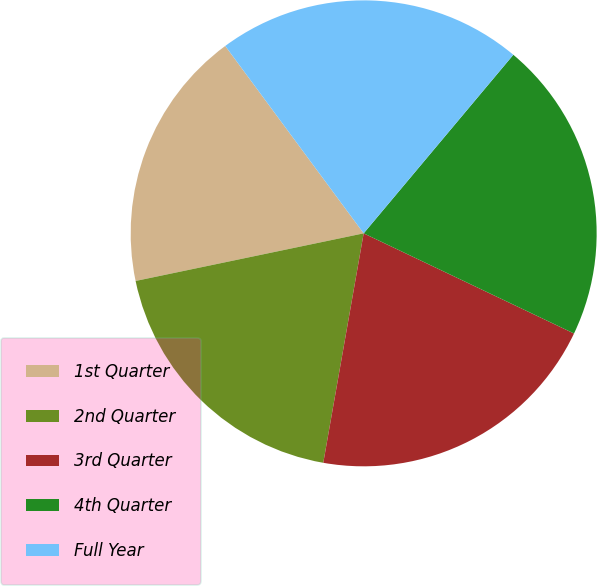<chart> <loc_0><loc_0><loc_500><loc_500><pie_chart><fcel>1st Quarter<fcel>2nd Quarter<fcel>3rd Quarter<fcel>4th Quarter<fcel>Full Year<nl><fcel>18.15%<fcel>18.95%<fcel>20.7%<fcel>20.97%<fcel>21.23%<nl></chart> 